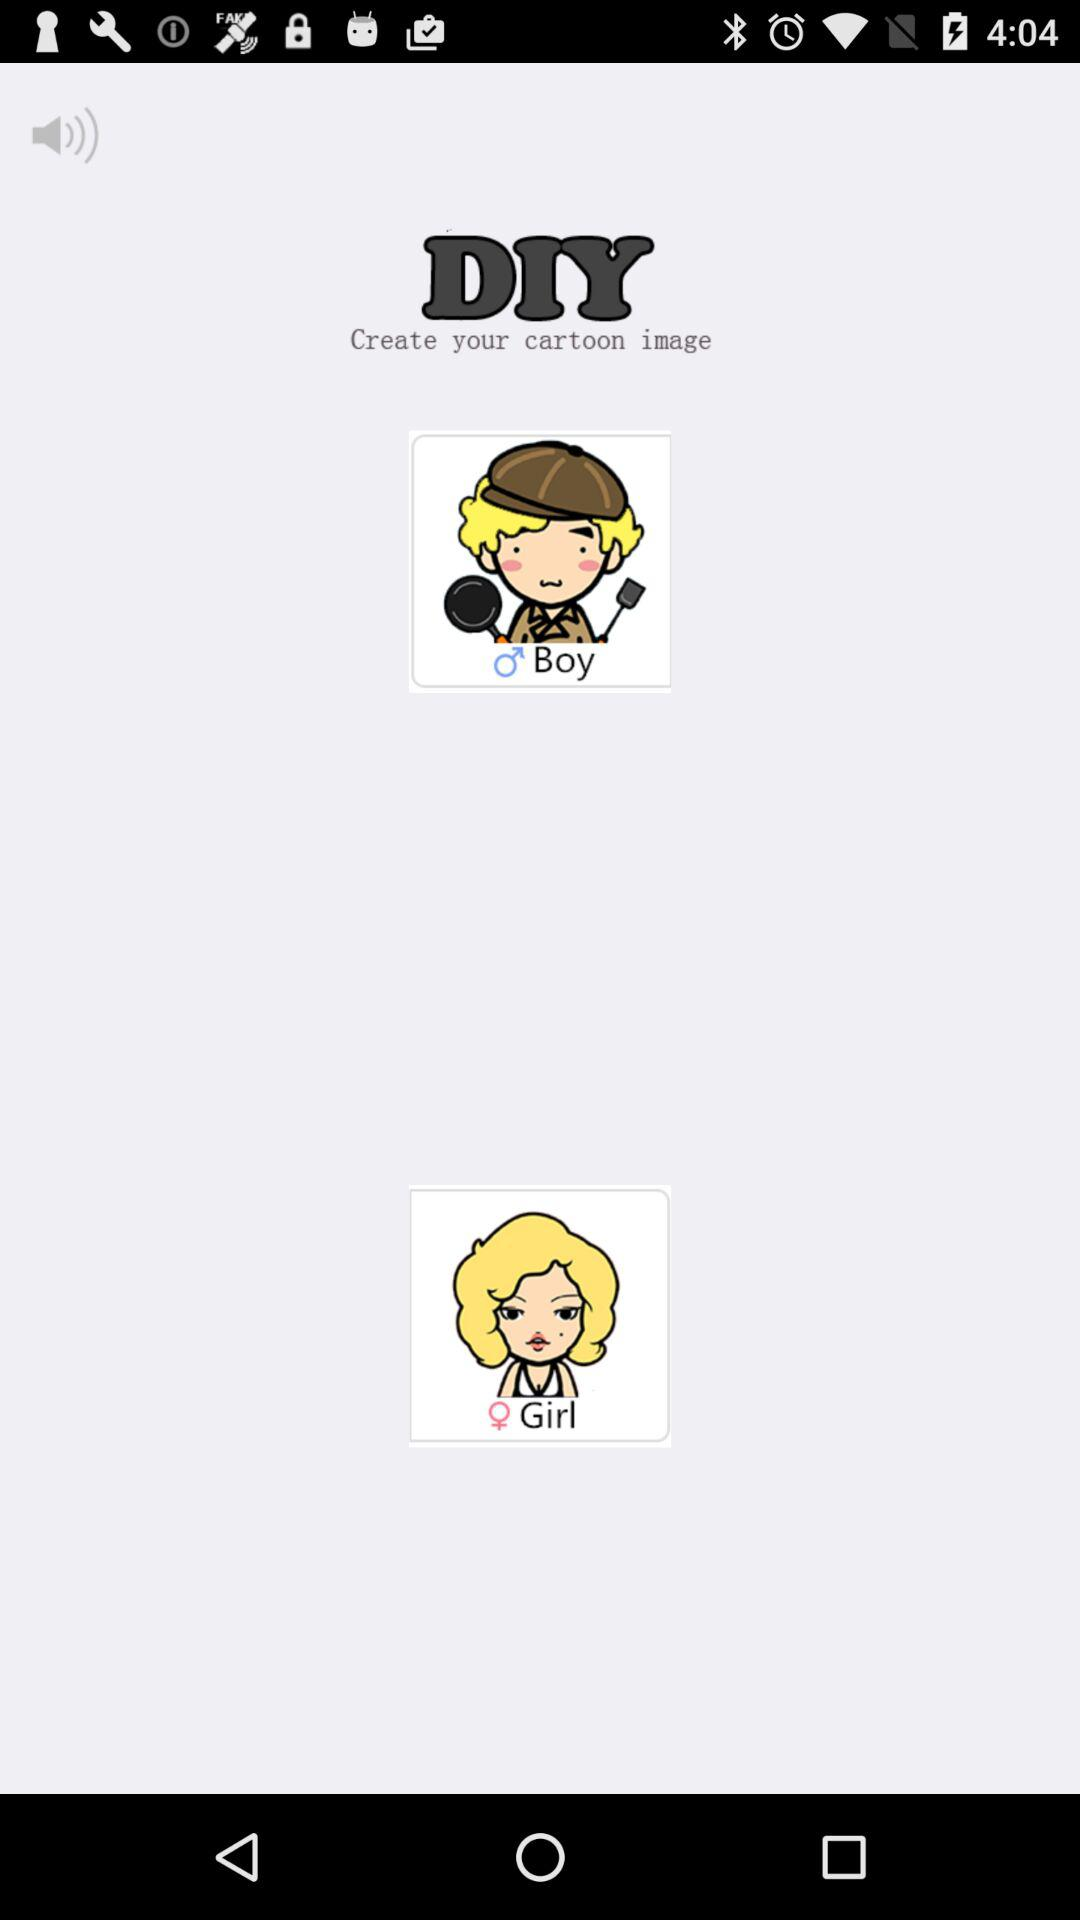How long does it take to create your cartoon image?
When the provided information is insufficient, respond with <no answer>. <no answer> 